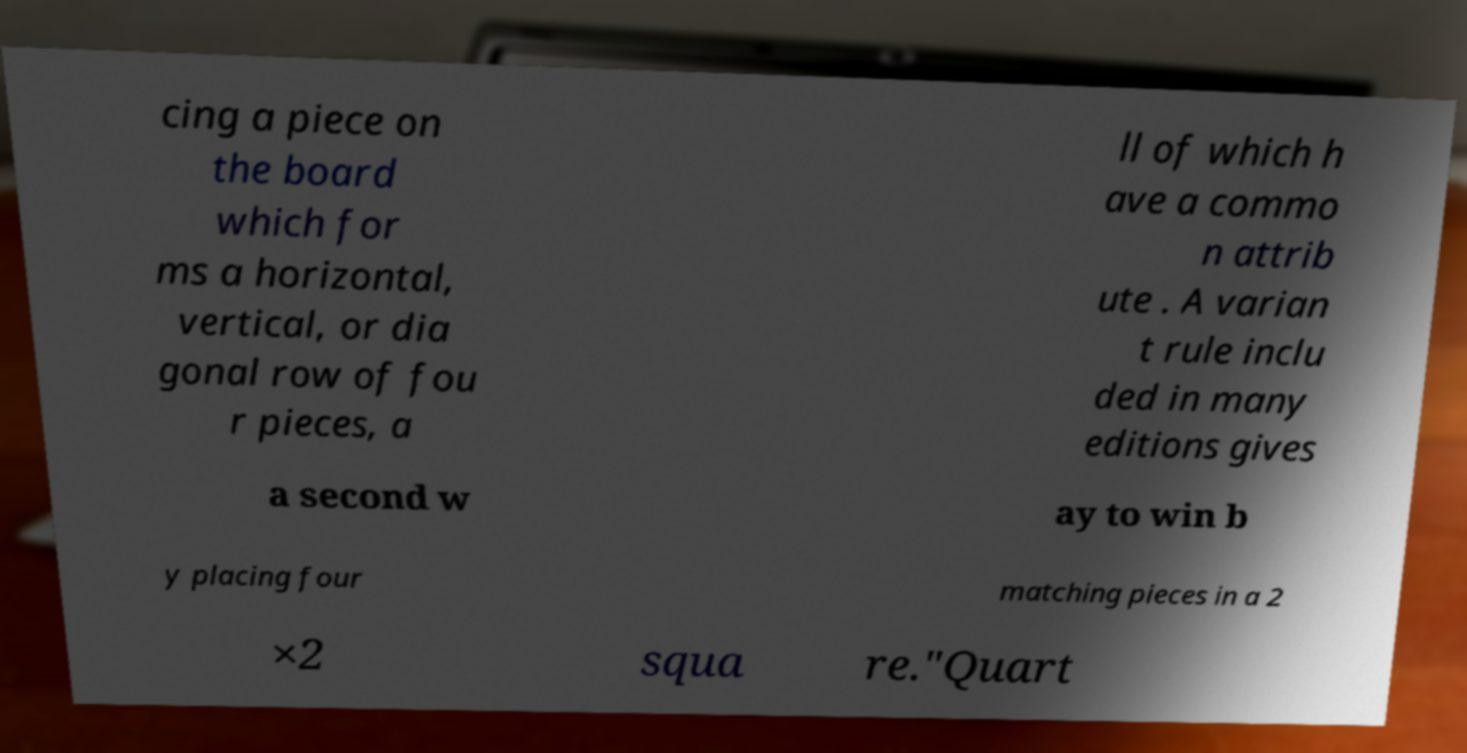Could you extract and type out the text from this image? cing a piece on the board which for ms a horizontal, vertical, or dia gonal row of fou r pieces, a ll of which h ave a commo n attrib ute . A varian t rule inclu ded in many editions gives a second w ay to win b y placing four matching pieces in a 2 ×2 squa re."Quart 